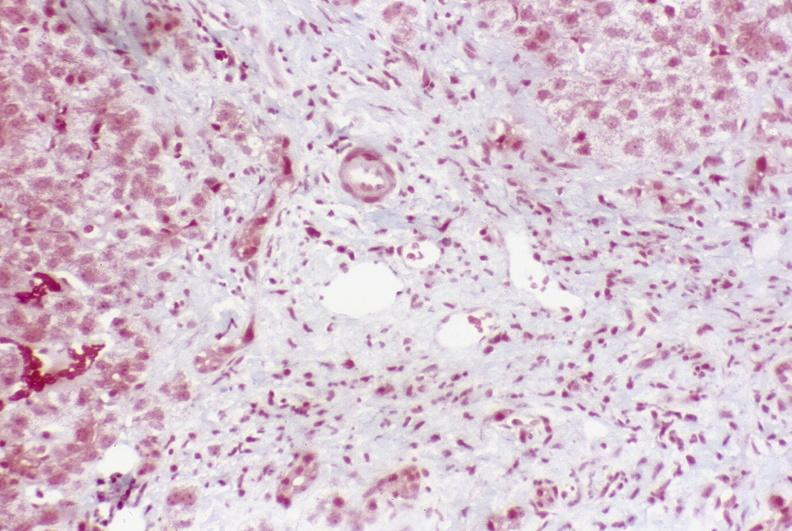s liver present?
Answer the question using a single word or phrase. Yes 